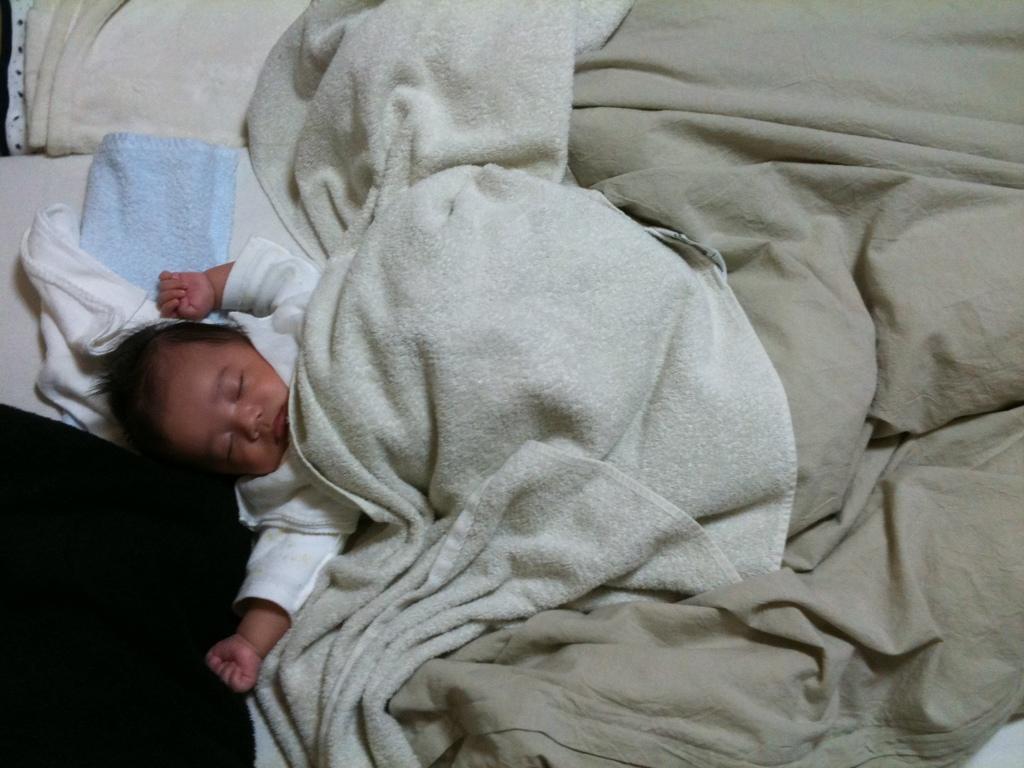Describe this image in one or two sentences. In this image, we can see a baby lying on bed and covered by a blanket. 